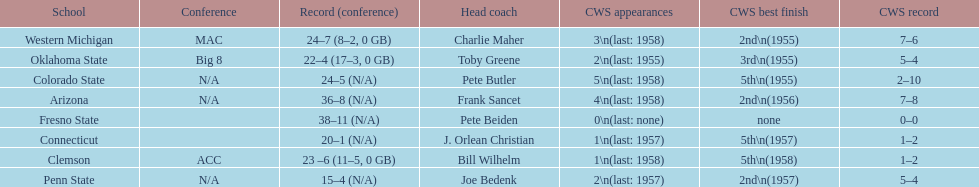List the schools that came in last place in the cws best finish. Clemson, Colorado State, Connecticut. 